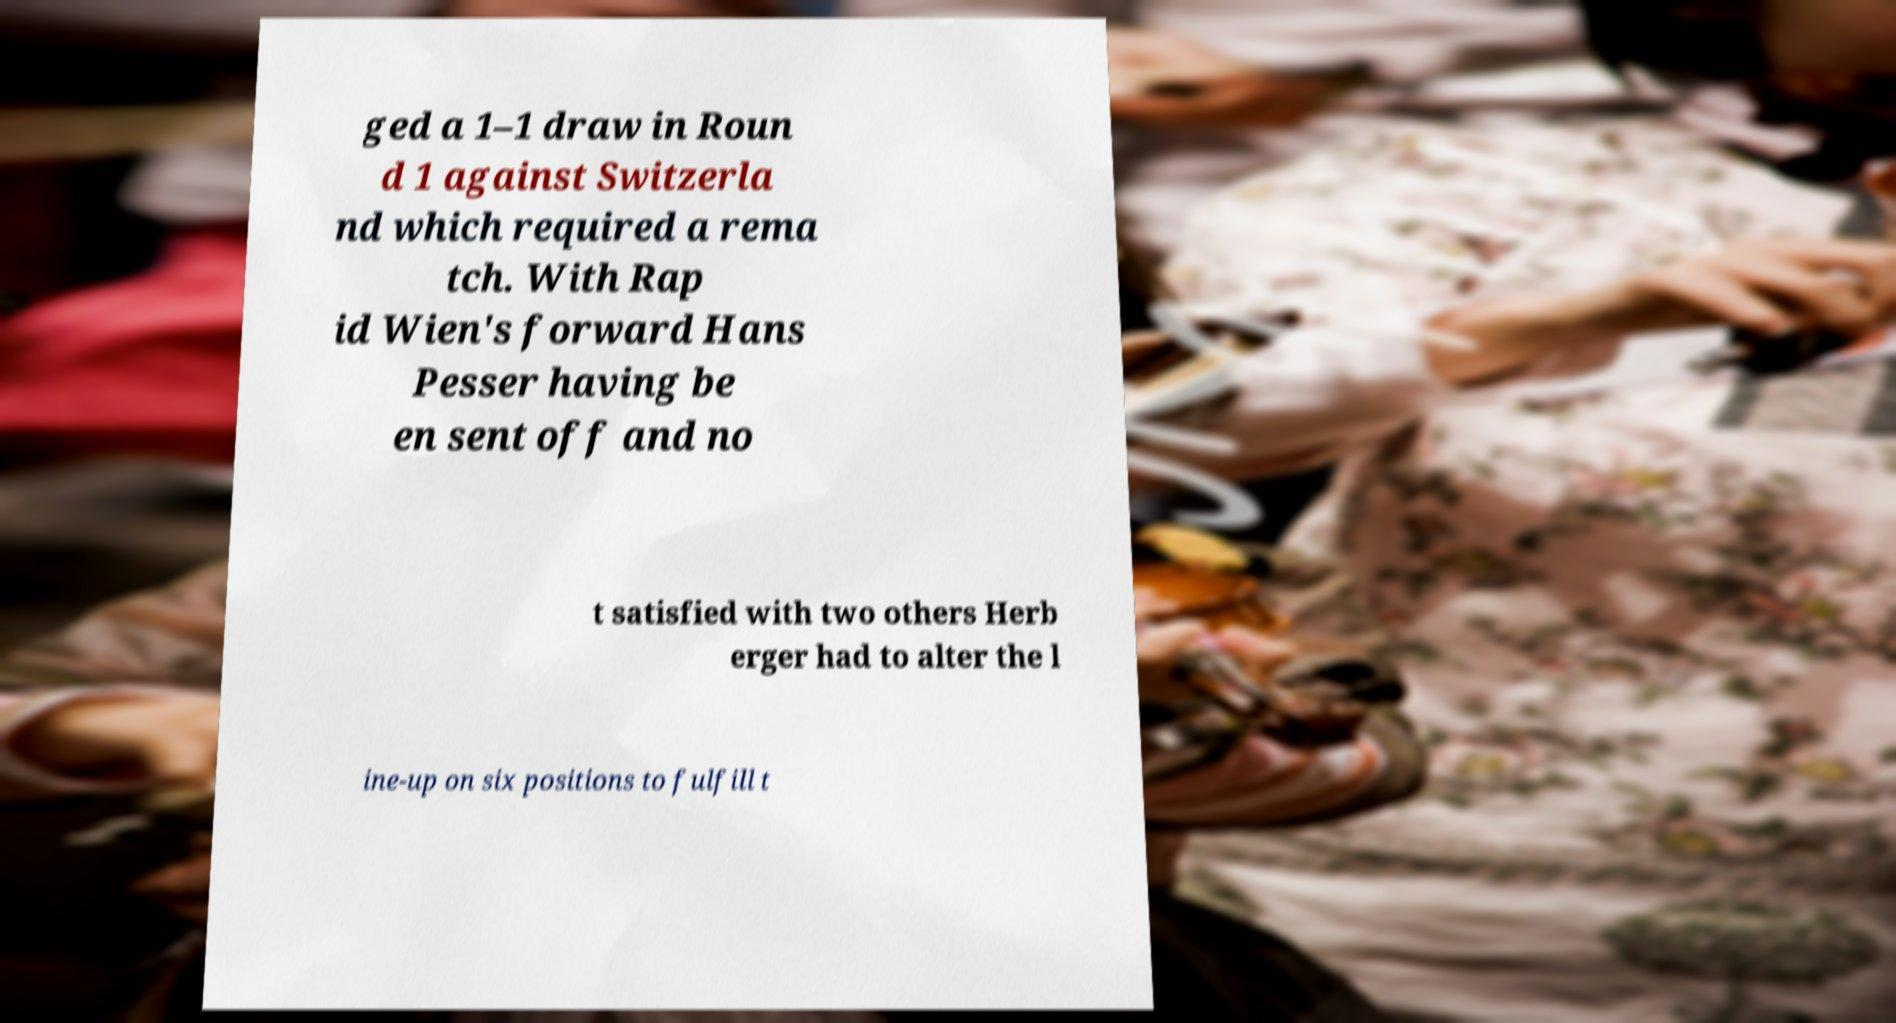I need the written content from this picture converted into text. Can you do that? ged a 1–1 draw in Roun d 1 against Switzerla nd which required a rema tch. With Rap id Wien's forward Hans Pesser having be en sent off and no t satisfied with two others Herb erger had to alter the l ine-up on six positions to fulfill t 